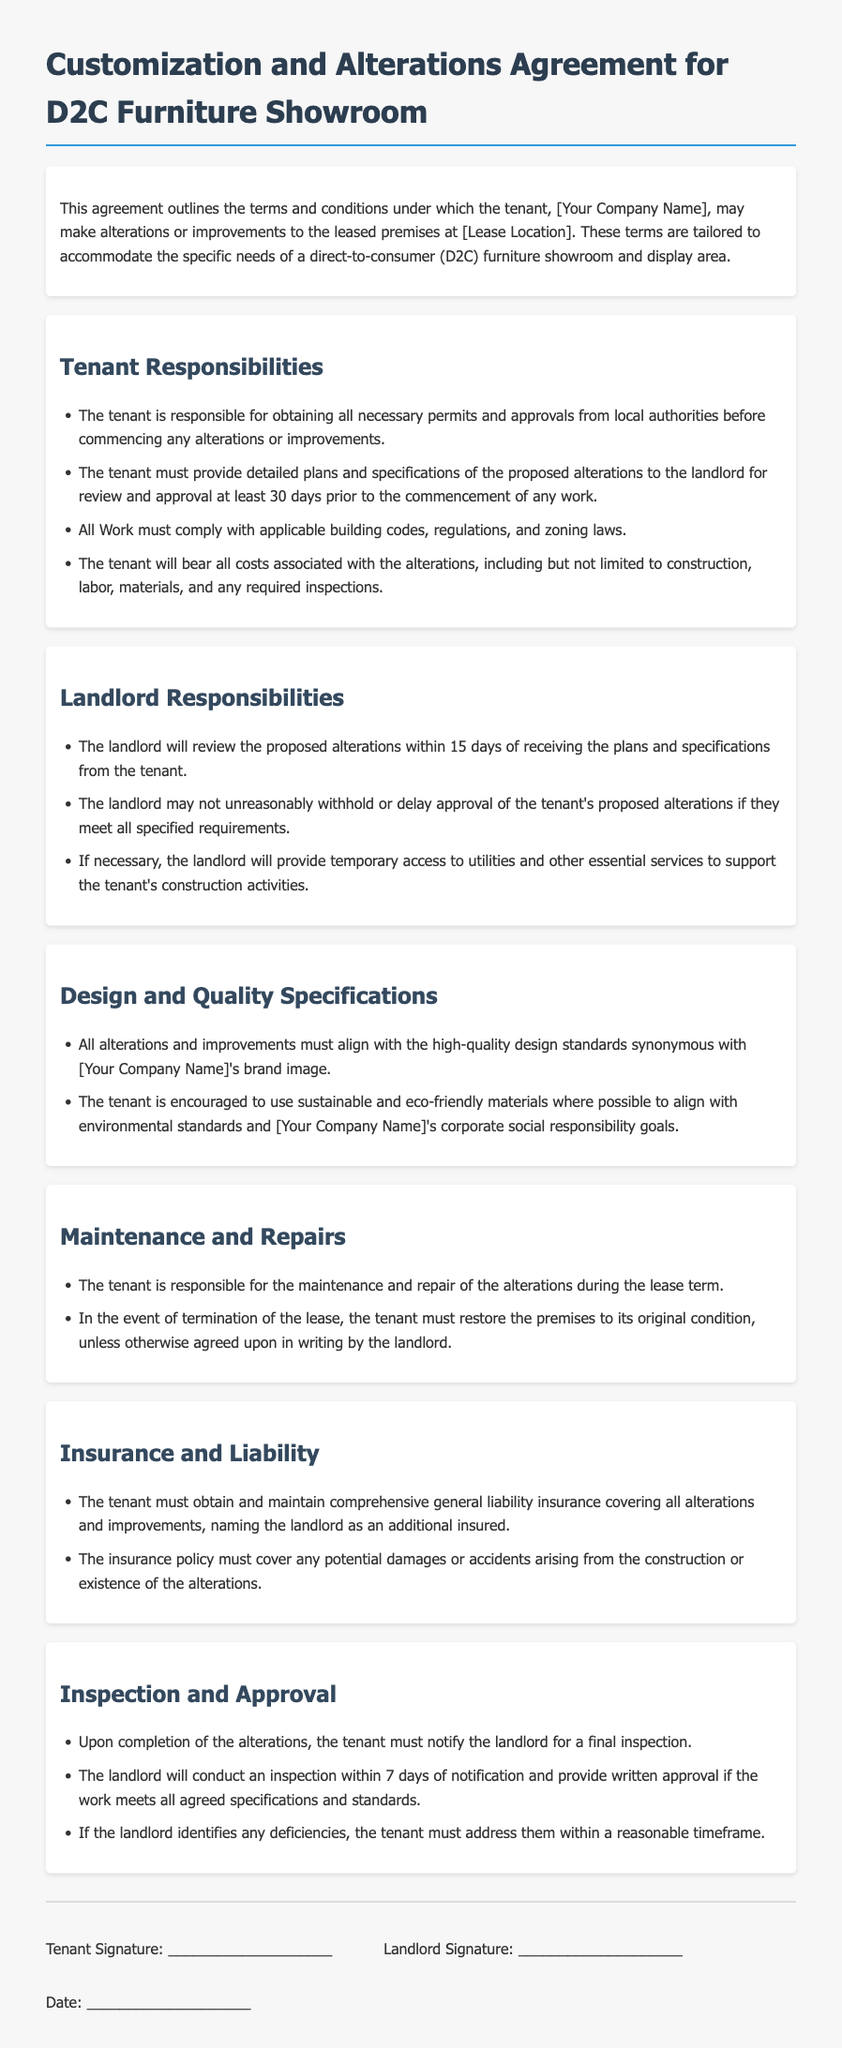what is the tenant's responsibility for permits? The tenant is responsible for obtaining all necessary permits and approvals from local authorities before commencing any alterations or improvements.
Answer: obtaining permits how many days prior must plans be submitted for review? The document states that the tenant must provide detailed plans and specifications at least 30 days prior to the commencement of any work.
Answer: 30 days what is the landlord's review period for proposed alterations? The landlord will review the proposed alterations within 15 days of receiving the plans and specifications from the tenant.
Answer: 15 days what is the tenant's obligation after the lease termination? In the event of termination of the lease, the tenant must restore the premises to its original condition.
Answer: restore premises what must the tenant maintain during the lease term? The tenant is responsible for the maintenance and repair of the alterations during the lease term.
Answer: maintenance and repair what type of insurance must the tenant obtain? The tenant must obtain and maintain comprehensive general liability insurance covering all alterations and improvements.
Answer: comprehensive general liability insurance what is required for the alterations to align with the brand image? All alterations and improvements must align with the high-quality design standards synonymous with [Your Company Name]'s brand image.
Answer: high-quality design standards when must the landlord conduct a final inspection? The landlord will conduct an inspection within 7 days of notification of completion from the tenant.
Answer: 7 days what must be provided if the landlord identifies deficiencies? If the landlord identifies any deficiencies, the tenant must address them within a reasonable timeframe.
Answer: address deficiencies 